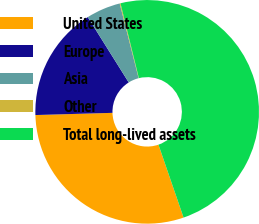Convert chart. <chart><loc_0><loc_0><loc_500><loc_500><pie_chart><fcel>United States<fcel>Europe<fcel>Asia<fcel>Other<fcel>Total long-lived assets<nl><fcel>29.82%<fcel>16.54%<fcel>4.96%<fcel>0.12%<fcel>48.55%<nl></chart> 